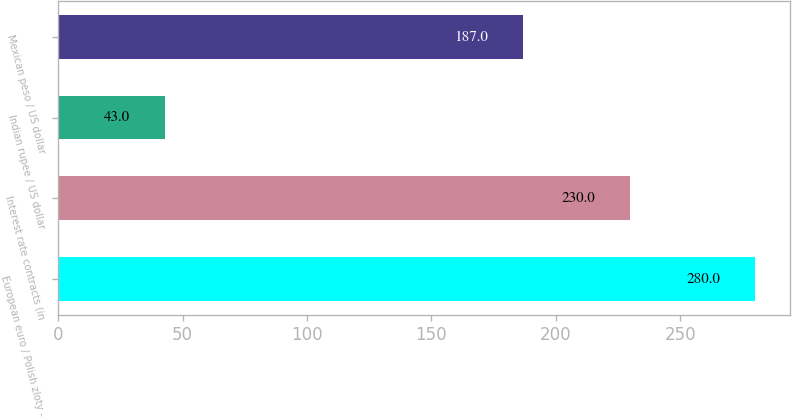Convert chart. <chart><loc_0><loc_0><loc_500><loc_500><bar_chart><fcel>European euro / Polish zloty -<fcel>Interest rate contracts (in<fcel>Indian rupee / US dollar<fcel>Mexican peso / US dollar<nl><fcel>280<fcel>230<fcel>43<fcel>187<nl></chart> 